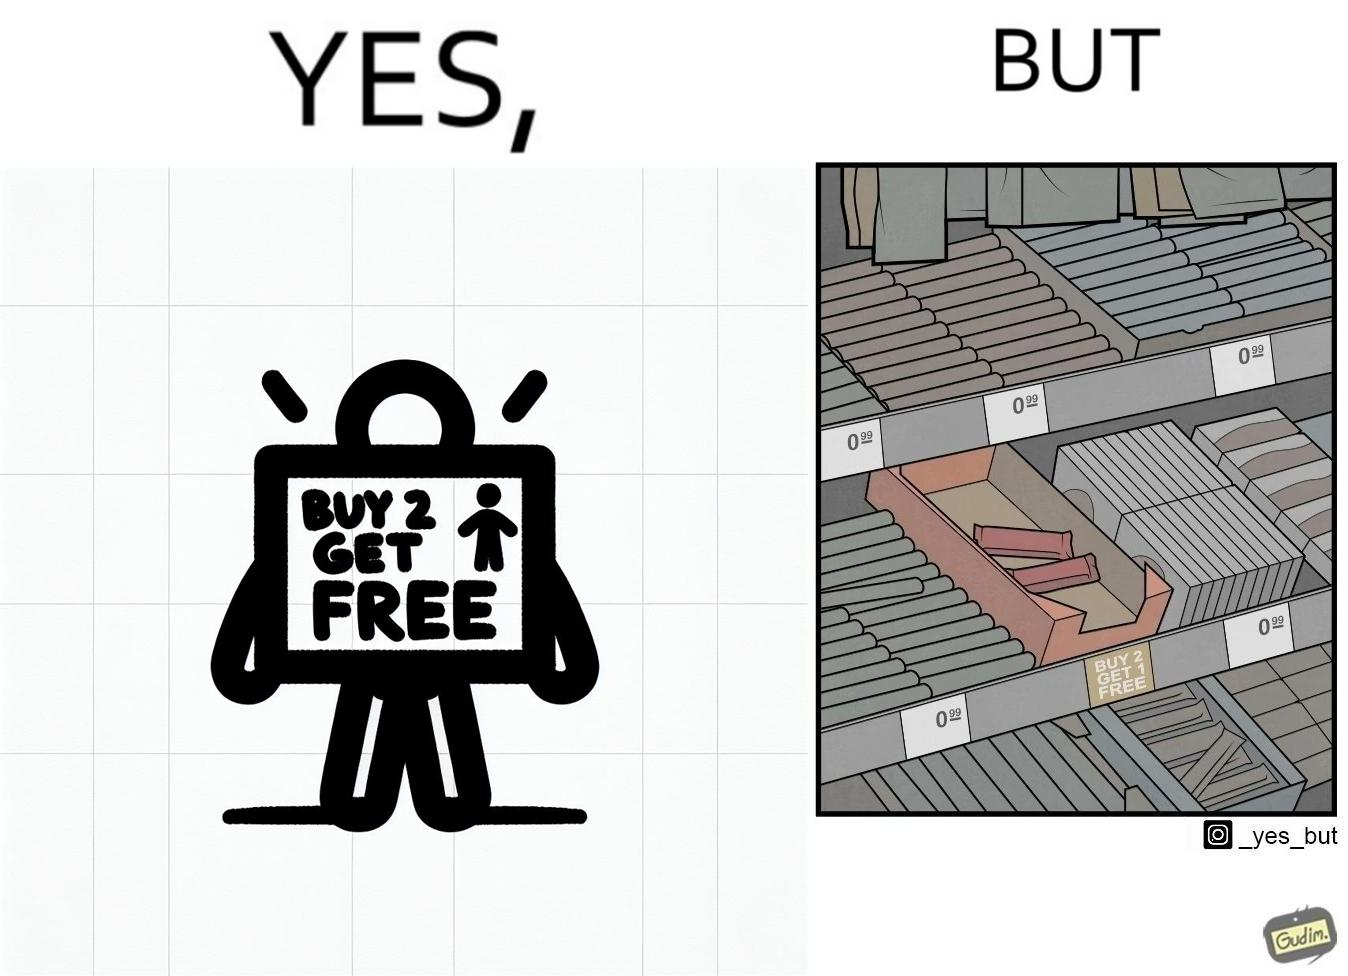What does this image depict? The image is funny because while there is an offer that lets the buyer have a free item if they buy two items of the product, there is only two units left which means that the buyer won't get the free unit. 